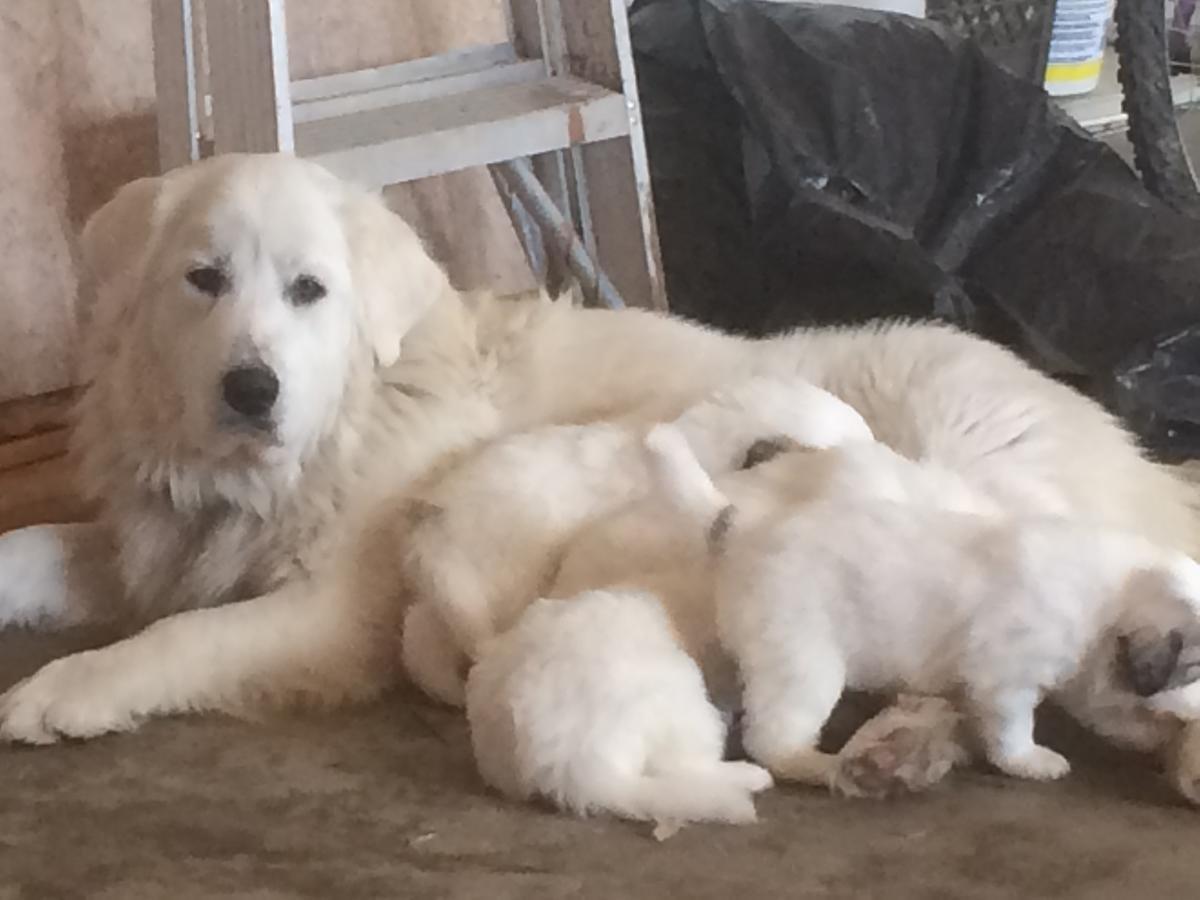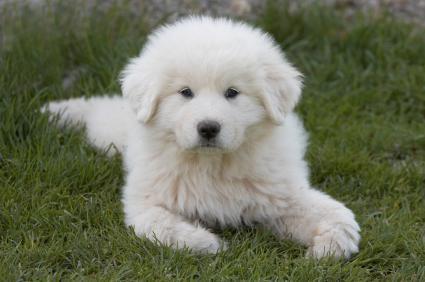The first image is the image on the left, the second image is the image on the right. Assess this claim about the two images: "Each image contains no more than one white dog, the dog in the right image is outdoors, and at least one dog wears a collar.". Correct or not? Answer yes or no. No. The first image is the image on the left, the second image is the image on the right. Given the left and right images, does the statement "One dog has its mouth open." hold true? Answer yes or no. No. 